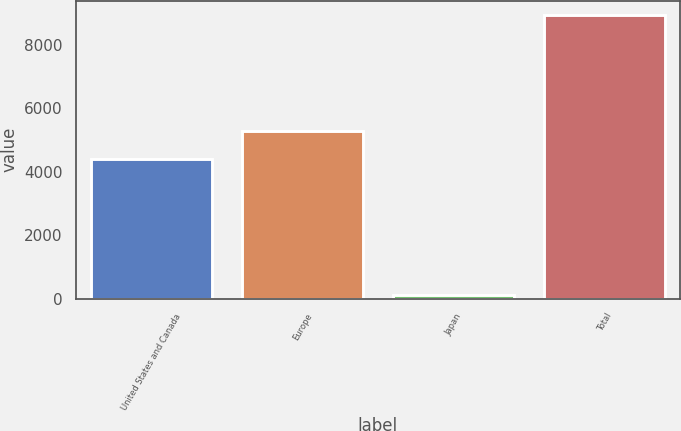Convert chart. <chart><loc_0><loc_0><loc_500><loc_500><bar_chart><fcel>United States and Canada<fcel>Europe<fcel>Japan<fcel>Total<nl><fcel>4402<fcel>5284.3<fcel>117<fcel>8940<nl></chart> 